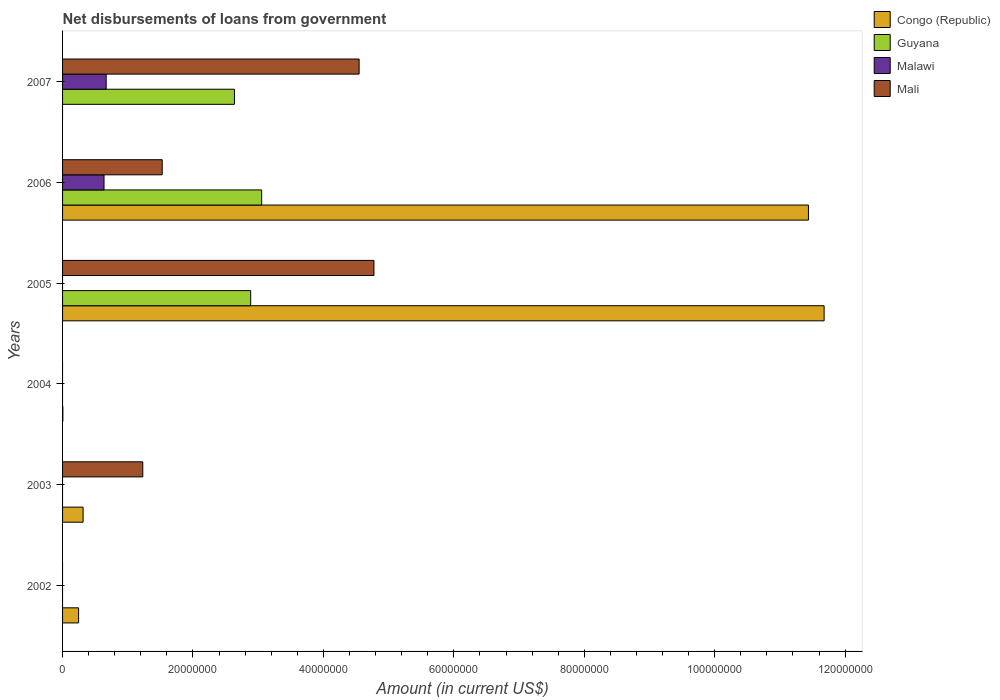Are the number of bars per tick equal to the number of legend labels?
Keep it short and to the point. No. What is the label of the 3rd group of bars from the top?
Offer a very short reply. 2005. In how many cases, is the number of bars for a given year not equal to the number of legend labels?
Give a very brief answer. 5. Across all years, what is the maximum amount of loan disbursed from government in Mali?
Give a very brief answer. 4.78e+07. What is the total amount of loan disbursed from government in Mali in the graph?
Provide a succinct answer. 1.21e+08. What is the difference between the amount of loan disbursed from government in Mali in 2003 and that in 2006?
Offer a terse response. -2.98e+06. What is the difference between the amount of loan disbursed from government in Congo (Republic) in 2005 and the amount of loan disbursed from government in Mali in 2002?
Give a very brief answer. 1.17e+08. What is the average amount of loan disbursed from government in Guyana per year?
Ensure brevity in your answer.  1.43e+07. In the year 2003, what is the difference between the amount of loan disbursed from government in Congo (Republic) and amount of loan disbursed from government in Mali?
Provide a succinct answer. -9.15e+06. In how many years, is the amount of loan disbursed from government in Guyana greater than 108000000 US$?
Ensure brevity in your answer.  0. What is the ratio of the amount of loan disbursed from government in Congo (Republic) in 2004 to that in 2006?
Your response must be concise. 0. What is the difference between the highest and the second highest amount of loan disbursed from government in Congo (Republic)?
Your response must be concise. 2.40e+06. What is the difference between the highest and the lowest amount of loan disbursed from government in Congo (Republic)?
Provide a succinct answer. 1.17e+08. Is it the case that in every year, the sum of the amount of loan disbursed from government in Malawi and amount of loan disbursed from government in Congo (Republic) is greater than the sum of amount of loan disbursed from government in Guyana and amount of loan disbursed from government in Mali?
Your answer should be compact. No. How many years are there in the graph?
Make the answer very short. 6. What is the difference between two consecutive major ticks on the X-axis?
Ensure brevity in your answer.  2.00e+07. Are the values on the major ticks of X-axis written in scientific E-notation?
Offer a very short reply. No. How many legend labels are there?
Your response must be concise. 4. How are the legend labels stacked?
Your answer should be very brief. Vertical. What is the title of the graph?
Keep it short and to the point. Net disbursements of loans from government. Does "Eritrea" appear as one of the legend labels in the graph?
Provide a succinct answer. No. What is the Amount (in current US$) of Congo (Republic) in 2002?
Provide a succinct answer. 2.46e+06. What is the Amount (in current US$) of Guyana in 2002?
Make the answer very short. 0. What is the Amount (in current US$) of Congo (Republic) in 2003?
Provide a succinct answer. 3.15e+06. What is the Amount (in current US$) in Malawi in 2003?
Provide a short and direct response. 0. What is the Amount (in current US$) of Mali in 2003?
Make the answer very short. 1.23e+07. What is the Amount (in current US$) in Congo (Republic) in 2004?
Offer a terse response. 4.60e+04. What is the Amount (in current US$) in Mali in 2004?
Offer a terse response. 0. What is the Amount (in current US$) in Congo (Republic) in 2005?
Keep it short and to the point. 1.17e+08. What is the Amount (in current US$) of Guyana in 2005?
Offer a very short reply. 2.88e+07. What is the Amount (in current US$) of Malawi in 2005?
Give a very brief answer. 0. What is the Amount (in current US$) of Mali in 2005?
Offer a terse response. 4.78e+07. What is the Amount (in current US$) of Congo (Republic) in 2006?
Your answer should be very brief. 1.14e+08. What is the Amount (in current US$) of Guyana in 2006?
Provide a succinct answer. 3.05e+07. What is the Amount (in current US$) of Malawi in 2006?
Give a very brief answer. 6.36e+06. What is the Amount (in current US$) in Mali in 2006?
Keep it short and to the point. 1.53e+07. What is the Amount (in current US$) in Guyana in 2007?
Your answer should be compact. 2.64e+07. What is the Amount (in current US$) in Malawi in 2007?
Provide a succinct answer. 6.68e+06. What is the Amount (in current US$) in Mali in 2007?
Provide a short and direct response. 4.55e+07. Across all years, what is the maximum Amount (in current US$) of Congo (Republic)?
Offer a terse response. 1.17e+08. Across all years, what is the maximum Amount (in current US$) in Guyana?
Keep it short and to the point. 3.05e+07. Across all years, what is the maximum Amount (in current US$) in Malawi?
Offer a very short reply. 6.68e+06. Across all years, what is the maximum Amount (in current US$) in Mali?
Offer a very short reply. 4.78e+07. Across all years, what is the minimum Amount (in current US$) of Malawi?
Provide a short and direct response. 0. What is the total Amount (in current US$) of Congo (Republic) in the graph?
Give a very brief answer. 2.37e+08. What is the total Amount (in current US$) of Guyana in the graph?
Keep it short and to the point. 8.57e+07. What is the total Amount (in current US$) of Malawi in the graph?
Give a very brief answer. 1.30e+07. What is the total Amount (in current US$) in Mali in the graph?
Your answer should be very brief. 1.21e+08. What is the difference between the Amount (in current US$) in Congo (Republic) in 2002 and that in 2003?
Provide a succinct answer. -6.88e+05. What is the difference between the Amount (in current US$) in Congo (Republic) in 2002 and that in 2004?
Your answer should be very brief. 2.42e+06. What is the difference between the Amount (in current US$) in Congo (Republic) in 2002 and that in 2005?
Give a very brief answer. -1.14e+08. What is the difference between the Amount (in current US$) in Congo (Republic) in 2002 and that in 2006?
Your answer should be compact. -1.12e+08. What is the difference between the Amount (in current US$) of Congo (Republic) in 2003 and that in 2004?
Your answer should be compact. 3.10e+06. What is the difference between the Amount (in current US$) in Congo (Republic) in 2003 and that in 2005?
Give a very brief answer. -1.14e+08. What is the difference between the Amount (in current US$) in Mali in 2003 and that in 2005?
Ensure brevity in your answer.  -3.54e+07. What is the difference between the Amount (in current US$) of Congo (Republic) in 2003 and that in 2006?
Ensure brevity in your answer.  -1.11e+08. What is the difference between the Amount (in current US$) in Mali in 2003 and that in 2006?
Keep it short and to the point. -2.98e+06. What is the difference between the Amount (in current US$) in Mali in 2003 and that in 2007?
Provide a short and direct response. -3.32e+07. What is the difference between the Amount (in current US$) of Congo (Republic) in 2004 and that in 2005?
Make the answer very short. -1.17e+08. What is the difference between the Amount (in current US$) in Congo (Republic) in 2004 and that in 2006?
Your answer should be very brief. -1.14e+08. What is the difference between the Amount (in current US$) in Congo (Republic) in 2005 and that in 2006?
Your answer should be very brief. 2.40e+06. What is the difference between the Amount (in current US$) of Guyana in 2005 and that in 2006?
Ensure brevity in your answer.  -1.68e+06. What is the difference between the Amount (in current US$) in Mali in 2005 and that in 2006?
Ensure brevity in your answer.  3.25e+07. What is the difference between the Amount (in current US$) of Guyana in 2005 and that in 2007?
Make the answer very short. 2.49e+06. What is the difference between the Amount (in current US$) in Mali in 2005 and that in 2007?
Your answer should be compact. 2.27e+06. What is the difference between the Amount (in current US$) in Guyana in 2006 and that in 2007?
Your response must be concise. 4.17e+06. What is the difference between the Amount (in current US$) of Malawi in 2006 and that in 2007?
Your response must be concise. -3.26e+05. What is the difference between the Amount (in current US$) in Mali in 2006 and that in 2007?
Provide a succinct answer. -3.02e+07. What is the difference between the Amount (in current US$) of Congo (Republic) in 2002 and the Amount (in current US$) of Mali in 2003?
Offer a terse response. -9.84e+06. What is the difference between the Amount (in current US$) in Congo (Republic) in 2002 and the Amount (in current US$) in Guyana in 2005?
Your response must be concise. -2.64e+07. What is the difference between the Amount (in current US$) of Congo (Republic) in 2002 and the Amount (in current US$) of Mali in 2005?
Your response must be concise. -4.53e+07. What is the difference between the Amount (in current US$) in Congo (Republic) in 2002 and the Amount (in current US$) in Guyana in 2006?
Keep it short and to the point. -2.81e+07. What is the difference between the Amount (in current US$) of Congo (Republic) in 2002 and the Amount (in current US$) of Malawi in 2006?
Your answer should be compact. -3.90e+06. What is the difference between the Amount (in current US$) in Congo (Republic) in 2002 and the Amount (in current US$) in Mali in 2006?
Keep it short and to the point. -1.28e+07. What is the difference between the Amount (in current US$) in Congo (Republic) in 2002 and the Amount (in current US$) in Guyana in 2007?
Offer a terse response. -2.39e+07. What is the difference between the Amount (in current US$) of Congo (Republic) in 2002 and the Amount (in current US$) of Malawi in 2007?
Offer a very short reply. -4.22e+06. What is the difference between the Amount (in current US$) in Congo (Republic) in 2002 and the Amount (in current US$) in Mali in 2007?
Provide a succinct answer. -4.30e+07. What is the difference between the Amount (in current US$) of Congo (Republic) in 2003 and the Amount (in current US$) of Guyana in 2005?
Give a very brief answer. -2.57e+07. What is the difference between the Amount (in current US$) of Congo (Republic) in 2003 and the Amount (in current US$) of Mali in 2005?
Provide a succinct answer. -4.46e+07. What is the difference between the Amount (in current US$) of Congo (Republic) in 2003 and the Amount (in current US$) of Guyana in 2006?
Offer a terse response. -2.74e+07. What is the difference between the Amount (in current US$) in Congo (Republic) in 2003 and the Amount (in current US$) in Malawi in 2006?
Your answer should be compact. -3.21e+06. What is the difference between the Amount (in current US$) of Congo (Republic) in 2003 and the Amount (in current US$) of Mali in 2006?
Offer a very short reply. -1.21e+07. What is the difference between the Amount (in current US$) of Congo (Republic) in 2003 and the Amount (in current US$) of Guyana in 2007?
Provide a short and direct response. -2.32e+07. What is the difference between the Amount (in current US$) in Congo (Republic) in 2003 and the Amount (in current US$) in Malawi in 2007?
Ensure brevity in your answer.  -3.54e+06. What is the difference between the Amount (in current US$) in Congo (Republic) in 2003 and the Amount (in current US$) in Mali in 2007?
Make the answer very short. -4.23e+07. What is the difference between the Amount (in current US$) of Congo (Republic) in 2004 and the Amount (in current US$) of Guyana in 2005?
Give a very brief answer. -2.88e+07. What is the difference between the Amount (in current US$) in Congo (Republic) in 2004 and the Amount (in current US$) in Mali in 2005?
Offer a terse response. -4.77e+07. What is the difference between the Amount (in current US$) in Congo (Republic) in 2004 and the Amount (in current US$) in Guyana in 2006?
Give a very brief answer. -3.05e+07. What is the difference between the Amount (in current US$) in Congo (Republic) in 2004 and the Amount (in current US$) in Malawi in 2006?
Ensure brevity in your answer.  -6.31e+06. What is the difference between the Amount (in current US$) in Congo (Republic) in 2004 and the Amount (in current US$) in Mali in 2006?
Your answer should be compact. -1.52e+07. What is the difference between the Amount (in current US$) of Congo (Republic) in 2004 and the Amount (in current US$) of Guyana in 2007?
Offer a very short reply. -2.63e+07. What is the difference between the Amount (in current US$) of Congo (Republic) in 2004 and the Amount (in current US$) of Malawi in 2007?
Offer a terse response. -6.64e+06. What is the difference between the Amount (in current US$) of Congo (Republic) in 2004 and the Amount (in current US$) of Mali in 2007?
Ensure brevity in your answer.  -4.54e+07. What is the difference between the Amount (in current US$) of Congo (Republic) in 2005 and the Amount (in current US$) of Guyana in 2006?
Ensure brevity in your answer.  8.62e+07. What is the difference between the Amount (in current US$) of Congo (Republic) in 2005 and the Amount (in current US$) of Malawi in 2006?
Provide a short and direct response. 1.10e+08. What is the difference between the Amount (in current US$) of Congo (Republic) in 2005 and the Amount (in current US$) of Mali in 2006?
Give a very brief answer. 1.02e+08. What is the difference between the Amount (in current US$) in Guyana in 2005 and the Amount (in current US$) in Malawi in 2006?
Your answer should be compact. 2.25e+07. What is the difference between the Amount (in current US$) of Guyana in 2005 and the Amount (in current US$) of Mali in 2006?
Provide a short and direct response. 1.36e+07. What is the difference between the Amount (in current US$) of Congo (Republic) in 2005 and the Amount (in current US$) of Guyana in 2007?
Make the answer very short. 9.04e+07. What is the difference between the Amount (in current US$) in Congo (Republic) in 2005 and the Amount (in current US$) in Malawi in 2007?
Offer a very short reply. 1.10e+08. What is the difference between the Amount (in current US$) in Congo (Republic) in 2005 and the Amount (in current US$) in Mali in 2007?
Your answer should be very brief. 7.13e+07. What is the difference between the Amount (in current US$) in Guyana in 2005 and the Amount (in current US$) in Malawi in 2007?
Offer a terse response. 2.22e+07. What is the difference between the Amount (in current US$) of Guyana in 2005 and the Amount (in current US$) of Mali in 2007?
Offer a terse response. -1.66e+07. What is the difference between the Amount (in current US$) in Congo (Republic) in 2006 and the Amount (in current US$) in Guyana in 2007?
Keep it short and to the point. 8.80e+07. What is the difference between the Amount (in current US$) in Congo (Republic) in 2006 and the Amount (in current US$) in Malawi in 2007?
Provide a short and direct response. 1.08e+08. What is the difference between the Amount (in current US$) in Congo (Republic) in 2006 and the Amount (in current US$) in Mali in 2007?
Your answer should be compact. 6.89e+07. What is the difference between the Amount (in current US$) of Guyana in 2006 and the Amount (in current US$) of Malawi in 2007?
Ensure brevity in your answer.  2.38e+07. What is the difference between the Amount (in current US$) of Guyana in 2006 and the Amount (in current US$) of Mali in 2007?
Offer a terse response. -1.49e+07. What is the difference between the Amount (in current US$) in Malawi in 2006 and the Amount (in current US$) in Mali in 2007?
Offer a very short reply. -3.91e+07. What is the average Amount (in current US$) of Congo (Republic) per year?
Your answer should be very brief. 3.95e+07. What is the average Amount (in current US$) of Guyana per year?
Keep it short and to the point. 1.43e+07. What is the average Amount (in current US$) in Malawi per year?
Your answer should be compact. 2.17e+06. What is the average Amount (in current US$) of Mali per year?
Keep it short and to the point. 2.01e+07. In the year 2003, what is the difference between the Amount (in current US$) in Congo (Republic) and Amount (in current US$) in Mali?
Ensure brevity in your answer.  -9.15e+06. In the year 2005, what is the difference between the Amount (in current US$) in Congo (Republic) and Amount (in current US$) in Guyana?
Your answer should be very brief. 8.79e+07. In the year 2005, what is the difference between the Amount (in current US$) of Congo (Republic) and Amount (in current US$) of Mali?
Make the answer very short. 6.90e+07. In the year 2005, what is the difference between the Amount (in current US$) in Guyana and Amount (in current US$) in Mali?
Your answer should be very brief. -1.89e+07. In the year 2006, what is the difference between the Amount (in current US$) in Congo (Republic) and Amount (in current US$) in Guyana?
Offer a very short reply. 8.38e+07. In the year 2006, what is the difference between the Amount (in current US$) in Congo (Republic) and Amount (in current US$) in Malawi?
Your answer should be compact. 1.08e+08. In the year 2006, what is the difference between the Amount (in current US$) of Congo (Republic) and Amount (in current US$) of Mali?
Give a very brief answer. 9.91e+07. In the year 2006, what is the difference between the Amount (in current US$) of Guyana and Amount (in current US$) of Malawi?
Provide a short and direct response. 2.42e+07. In the year 2006, what is the difference between the Amount (in current US$) of Guyana and Amount (in current US$) of Mali?
Your answer should be compact. 1.52e+07. In the year 2006, what is the difference between the Amount (in current US$) of Malawi and Amount (in current US$) of Mali?
Give a very brief answer. -8.92e+06. In the year 2007, what is the difference between the Amount (in current US$) of Guyana and Amount (in current US$) of Malawi?
Provide a short and direct response. 1.97e+07. In the year 2007, what is the difference between the Amount (in current US$) of Guyana and Amount (in current US$) of Mali?
Make the answer very short. -1.91e+07. In the year 2007, what is the difference between the Amount (in current US$) in Malawi and Amount (in current US$) in Mali?
Keep it short and to the point. -3.88e+07. What is the ratio of the Amount (in current US$) in Congo (Republic) in 2002 to that in 2003?
Your answer should be compact. 0.78. What is the ratio of the Amount (in current US$) of Congo (Republic) in 2002 to that in 2004?
Your answer should be compact. 53.5. What is the ratio of the Amount (in current US$) in Congo (Republic) in 2002 to that in 2005?
Ensure brevity in your answer.  0.02. What is the ratio of the Amount (in current US$) of Congo (Republic) in 2002 to that in 2006?
Offer a terse response. 0.02. What is the ratio of the Amount (in current US$) in Congo (Republic) in 2003 to that in 2004?
Your answer should be compact. 68.46. What is the ratio of the Amount (in current US$) in Congo (Republic) in 2003 to that in 2005?
Make the answer very short. 0.03. What is the ratio of the Amount (in current US$) in Mali in 2003 to that in 2005?
Your answer should be very brief. 0.26. What is the ratio of the Amount (in current US$) in Congo (Republic) in 2003 to that in 2006?
Provide a short and direct response. 0.03. What is the ratio of the Amount (in current US$) of Mali in 2003 to that in 2006?
Your response must be concise. 0.81. What is the ratio of the Amount (in current US$) in Mali in 2003 to that in 2007?
Ensure brevity in your answer.  0.27. What is the ratio of the Amount (in current US$) in Congo (Republic) in 2004 to that in 2005?
Offer a terse response. 0. What is the ratio of the Amount (in current US$) of Congo (Republic) in 2004 to that in 2006?
Your answer should be compact. 0. What is the ratio of the Amount (in current US$) of Guyana in 2005 to that in 2006?
Offer a very short reply. 0.94. What is the ratio of the Amount (in current US$) of Mali in 2005 to that in 2006?
Your response must be concise. 3.12. What is the ratio of the Amount (in current US$) of Guyana in 2005 to that in 2007?
Offer a very short reply. 1.09. What is the ratio of the Amount (in current US$) in Mali in 2005 to that in 2007?
Your answer should be compact. 1.05. What is the ratio of the Amount (in current US$) of Guyana in 2006 to that in 2007?
Provide a succinct answer. 1.16. What is the ratio of the Amount (in current US$) of Malawi in 2006 to that in 2007?
Your response must be concise. 0.95. What is the ratio of the Amount (in current US$) of Mali in 2006 to that in 2007?
Keep it short and to the point. 0.34. What is the difference between the highest and the second highest Amount (in current US$) of Congo (Republic)?
Make the answer very short. 2.40e+06. What is the difference between the highest and the second highest Amount (in current US$) of Guyana?
Give a very brief answer. 1.68e+06. What is the difference between the highest and the second highest Amount (in current US$) of Mali?
Provide a short and direct response. 2.27e+06. What is the difference between the highest and the lowest Amount (in current US$) of Congo (Republic)?
Provide a succinct answer. 1.17e+08. What is the difference between the highest and the lowest Amount (in current US$) in Guyana?
Keep it short and to the point. 3.05e+07. What is the difference between the highest and the lowest Amount (in current US$) in Malawi?
Provide a short and direct response. 6.68e+06. What is the difference between the highest and the lowest Amount (in current US$) of Mali?
Your answer should be very brief. 4.78e+07. 